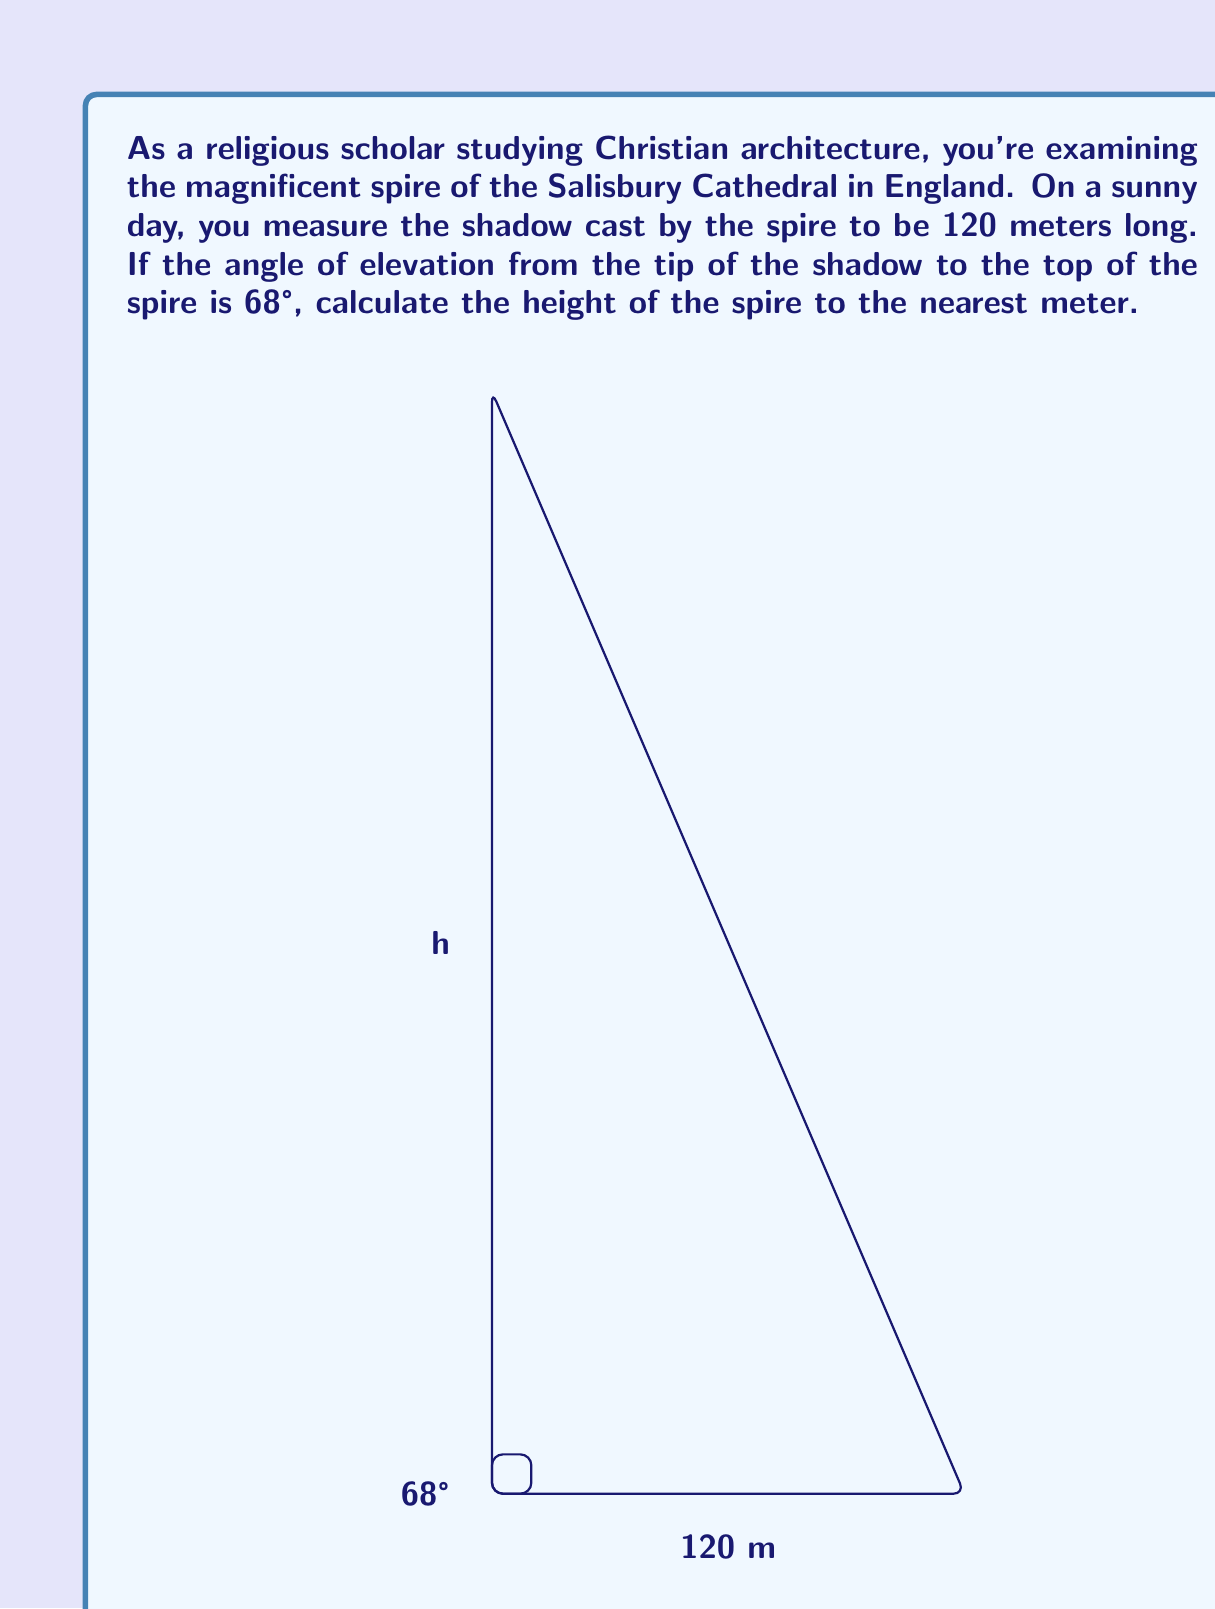Solve this math problem. To solve this problem, we'll use trigonometry, specifically the tangent function. Let's break it down step-by-step:

1) In a right triangle, tangent of an angle is the ratio of the opposite side to the adjacent side.

2) In this case, we have:
   - The adjacent side (shadow length) = 120 meters
   - The angle of elevation = 68°
   - The opposite side (spire height) is what we're trying to find

3) Let's call the height $h$. We can set up the equation:

   $$\tan(68°) = \frac{h}{120}$$

4) To solve for $h$, we multiply both sides by 120:

   $$h = 120 \cdot \tan(68°)$$

5) Now, let's calculate:
   $$\begin{align}
   h &= 120 \cdot \tan(68°) \\
   &= 120 \cdot 2.4751 \\
   &= 297.012 \text{ meters}
   \end{align}$$

6) Rounding to the nearest meter as requested:

   $h \approx 297 \text{ meters}$

This method uses the tangent function to relate the known angle and shadow length to the unknown height, allowing us to calculate the impressive height of the Salisbury Cathedral spire.
Answer: The height of the Salisbury Cathedral spire is approximately 297 meters. 